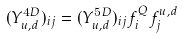<formula> <loc_0><loc_0><loc_500><loc_500>( Y ^ { 4 D } _ { u , d } ) _ { i j } = ( Y ^ { 5 D } _ { u , d } ) _ { i j } f _ { i } ^ { Q } f _ { j } ^ { u , d }</formula> 